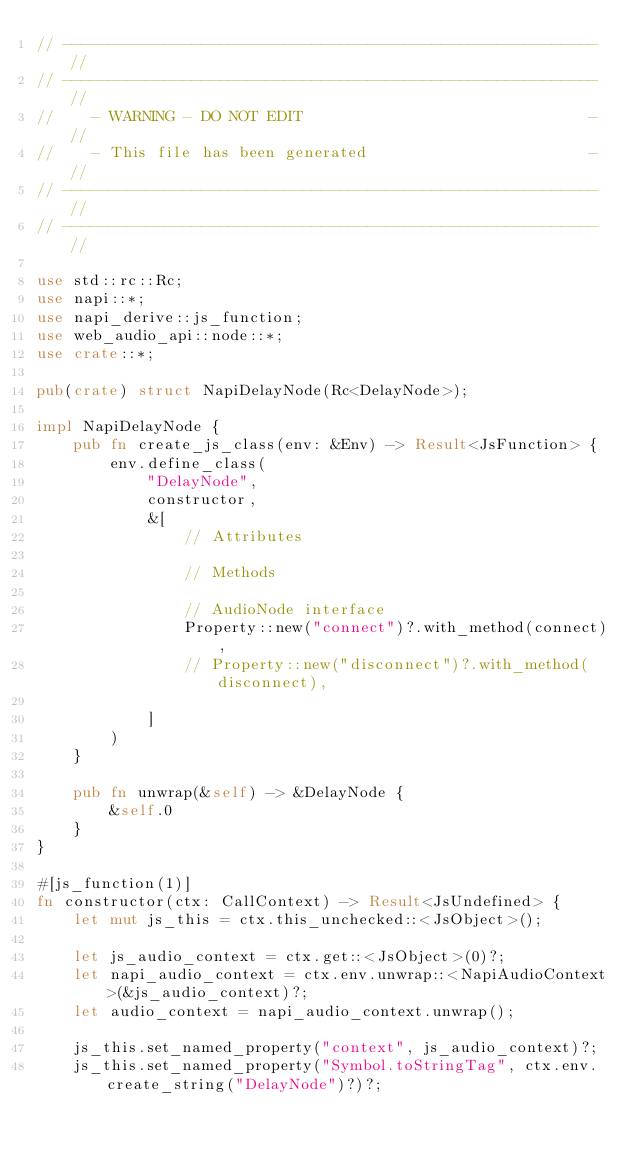<code> <loc_0><loc_0><loc_500><loc_500><_Rust_>// ---------------------------------------------------------- //
// ---------------------------------------------------------- //
//    - WARNING - DO NOT EDIT                               - //
//    - This file has been generated                        - //
// ---------------------------------------------------------- //
// ---------------------------------------------------------- //

use std::rc::Rc;
use napi::*;
use napi_derive::js_function;
use web_audio_api::node::*;
use crate::*;

pub(crate) struct NapiDelayNode(Rc<DelayNode>);

impl NapiDelayNode {
    pub fn create_js_class(env: &Env) -> Result<JsFunction> {
        env.define_class(
            "DelayNode",
            constructor,
            &[
                // Attributes
                
                // Methods
                
                // AudioNode interface
                Property::new("connect")?.with_method(connect),
                // Property::new("disconnect")?.with_method(disconnect),
                
            ]
        )
    }

    pub fn unwrap(&self) -> &DelayNode {
        &self.0
    }
}

#[js_function(1)]
fn constructor(ctx: CallContext) -> Result<JsUndefined> {
    let mut js_this = ctx.this_unchecked::<JsObject>();

    let js_audio_context = ctx.get::<JsObject>(0)?;
    let napi_audio_context = ctx.env.unwrap::<NapiAudioContext>(&js_audio_context)?;
    let audio_context = napi_audio_context.unwrap();

    js_this.set_named_property("context", js_audio_context)?;
    js_this.set_named_property("Symbol.toStringTag", ctx.env.create_string("DelayNode")?)?;
</code> 